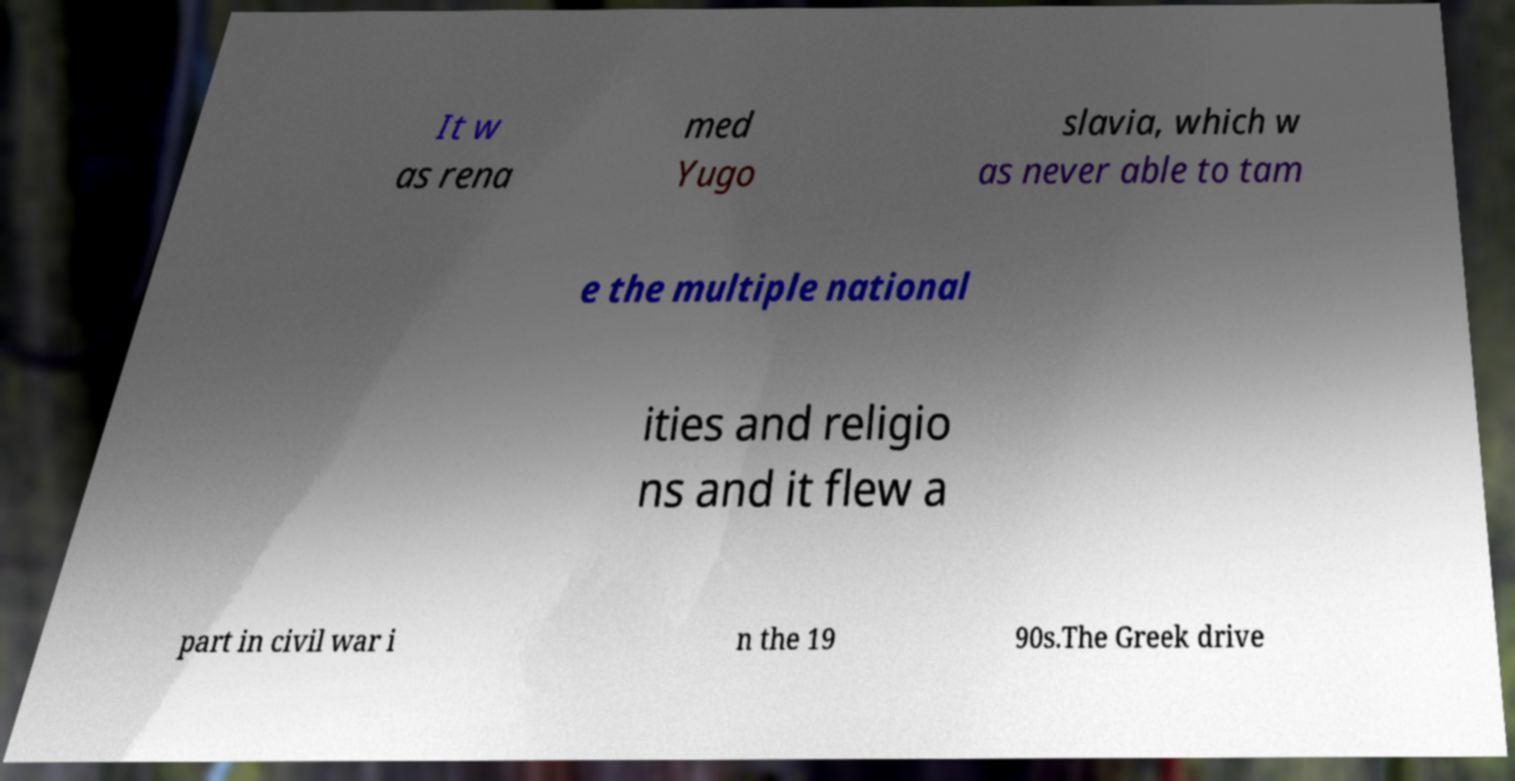Could you extract and type out the text from this image? It w as rena med Yugo slavia, which w as never able to tam e the multiple national ities and religio ns and it flew a part in civil war i n the 19 90s.The Greek drive 